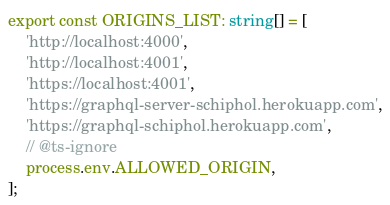<code> <loc_0><loc_0><loc_500><loc_500><_TypeScript_>export const ORIGINS_LIST: string[] = [
    'http://localhost:4000',
    'http://localhost:4001',
    'https://localhost:4001',
    'https://graphql-server-schiphol.herokuapp.com',
    'https://graphql-schiphol.herokuapp.com',
    // @ts-ignore
    process.env.ALLOWED_ORIGIN,
];
</code> 